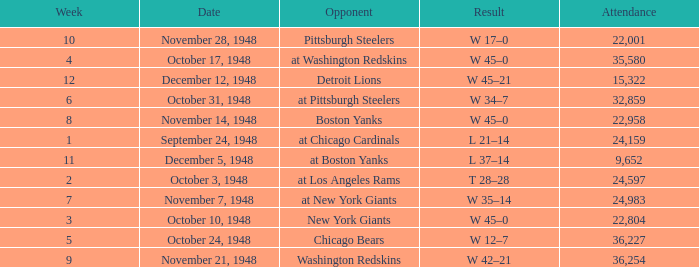What is the lowest value for Week, when the Attendance is greater than 22,958, and when the Opponent is At Chicago Cardinals? 1.0. 